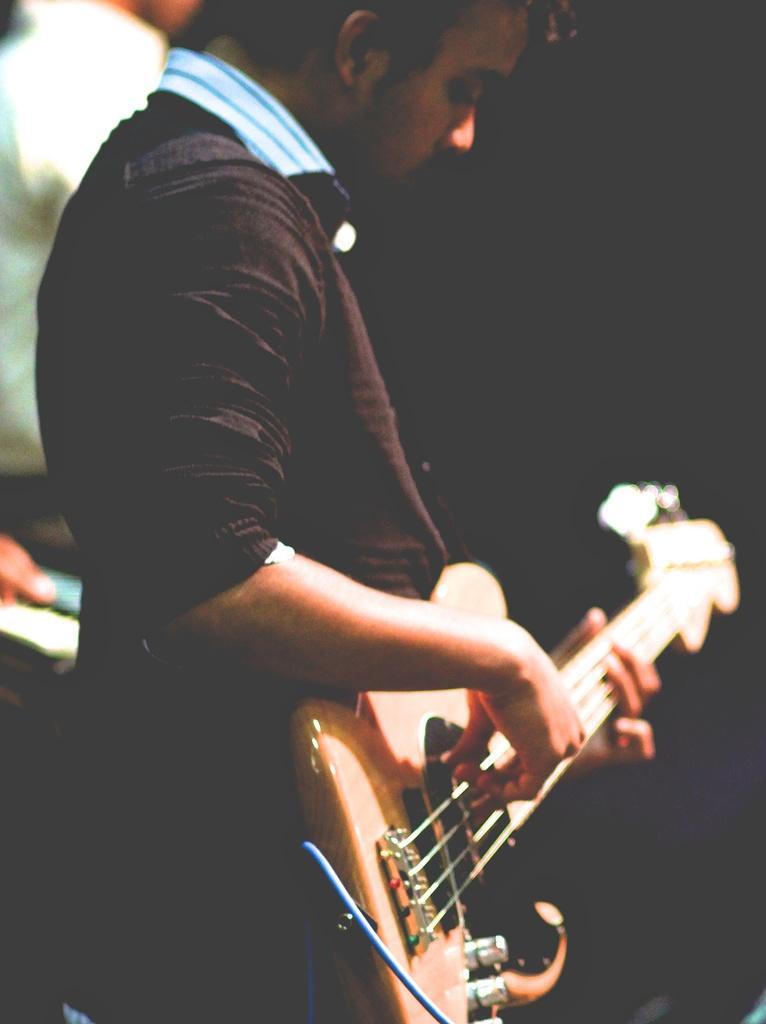Please provide a concise description of this image. In this Image I see a man who is holding the guitar. 